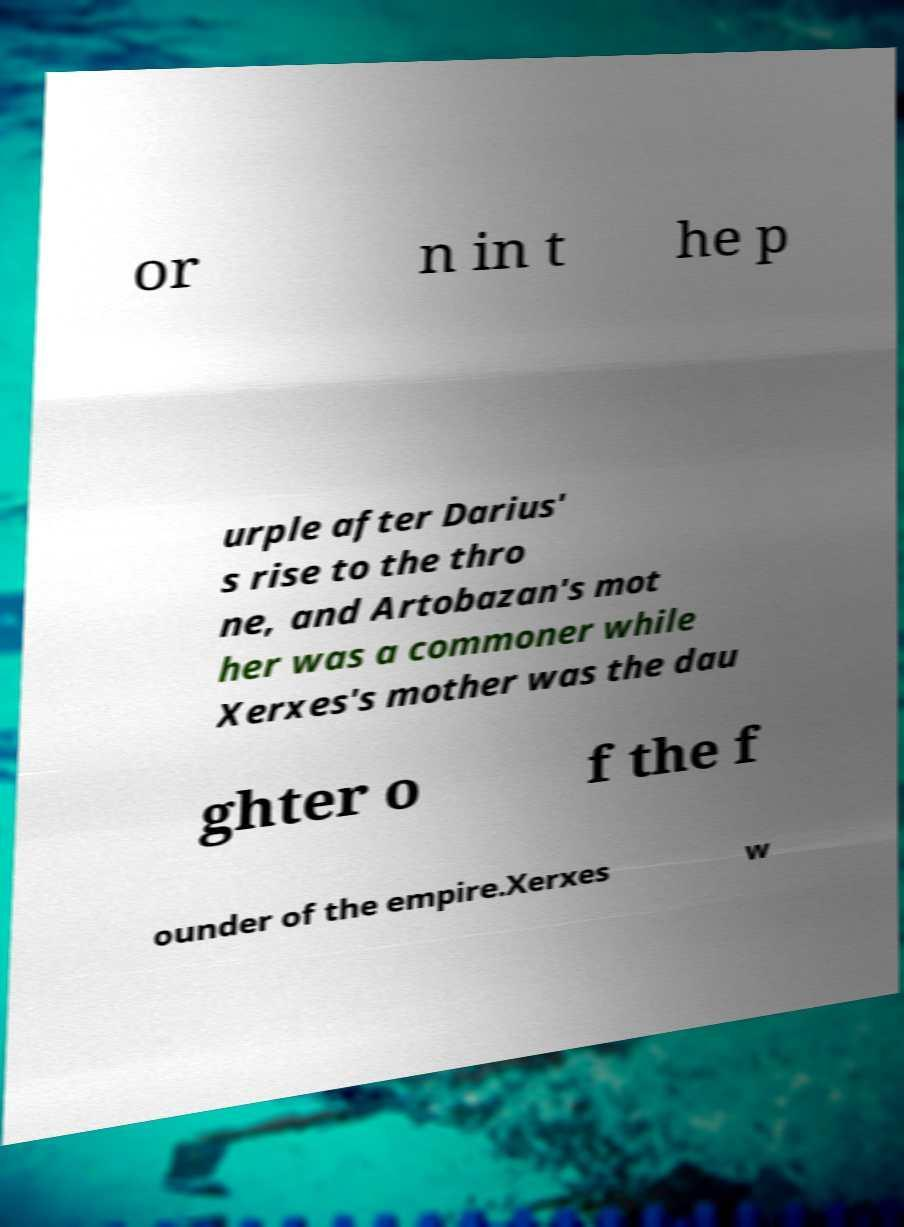There's text embedded in this image that I need extracted. Can you transcribe it verbatim? or n in t he p urple after Darius' s rise to the thro ne, and Artobazan's mot her was a commoner while Xerxes's mother was the dau ghter o f the f ounder of the empire.Xerxes w 